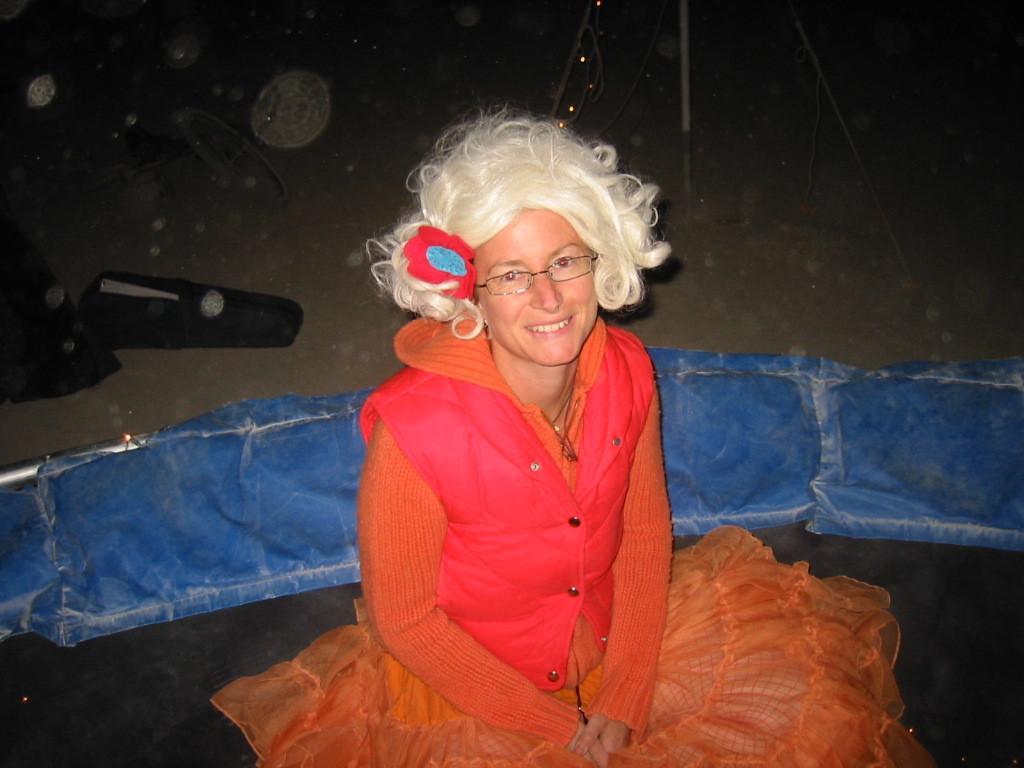Can you describe this image briefly? In this picture there is a woman sitting and smiling and we can see objects on the ground. 